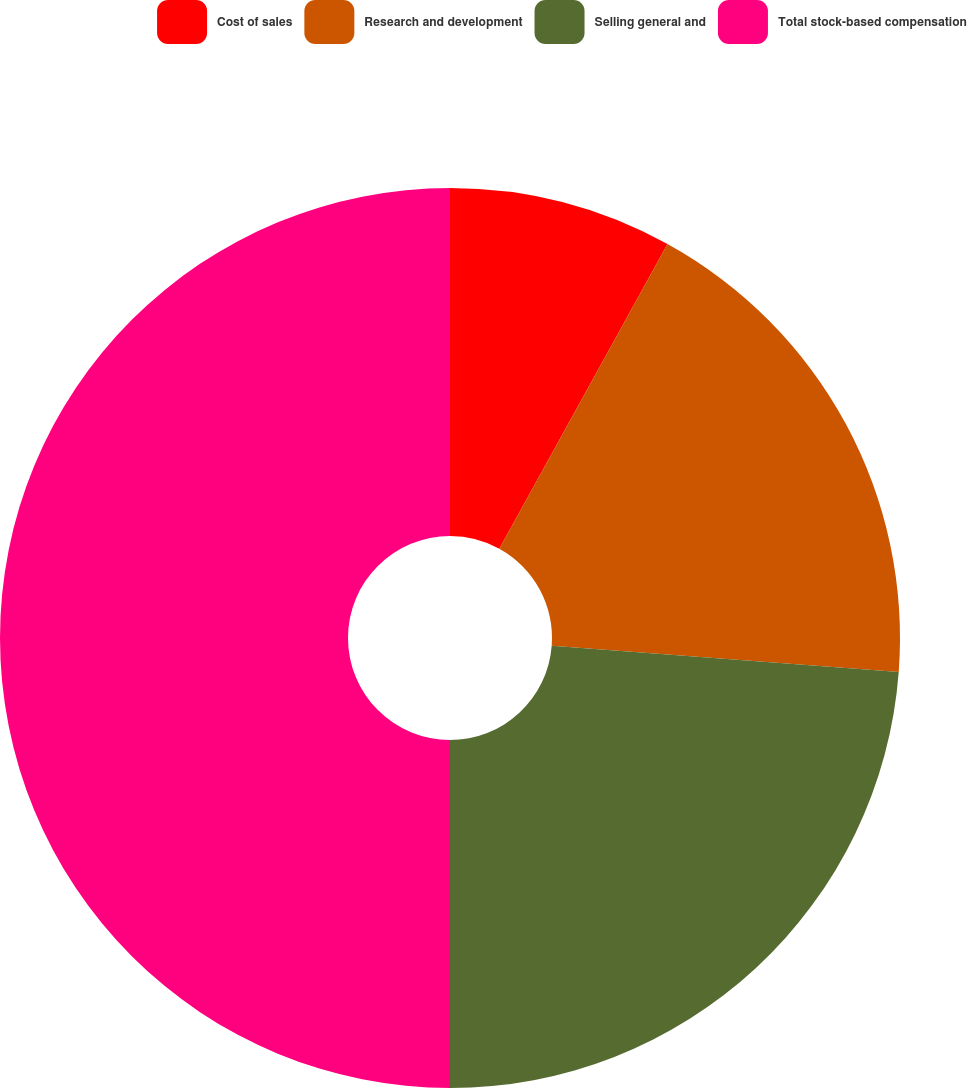<chart> <loc_0><loc_0><loc_500><loc_500><pie_chart><fcel>Cost of sales<fcel>Research and development<fcel>Selling general and<fcel>Total stock-based compensation<nl><fcel>8.03%<fcel>18.17%<fcel>23.8%<fcel>50.0%<nl></chart> 